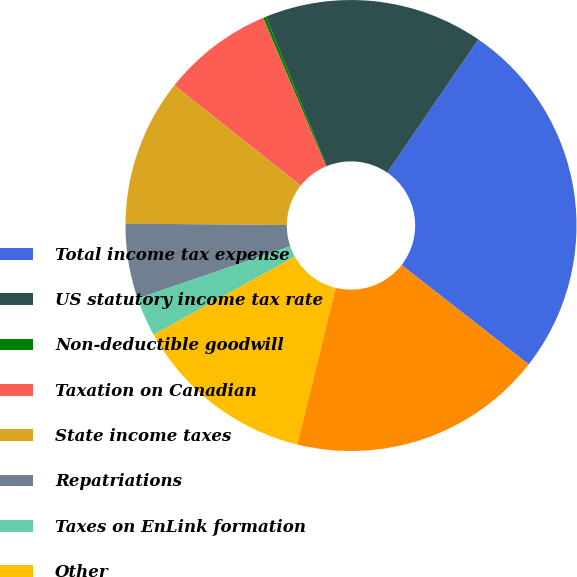Convert chart. <chart><loc_0><loc_0><loc_500><loc_500><pie_chart><fcel>Total income tax expense<fcel>US statutory income tax rate<fcel>Non-deductible goodwill<fcel>Taxation on Canadian<fcel>State income taxes<fcel>Repatriations<fcel>Taxes on EnLink formation<fcel>Other<fcel>Effective income tax rate<nl><fcel>26.0%<fcel>15.7%<fcel>0.22%<fcel>7.96%<fcel>10.54%<fcel>5.38%<fcel>2.8%<fcel>13.12%<fcel>18.27%<nl></chart> 